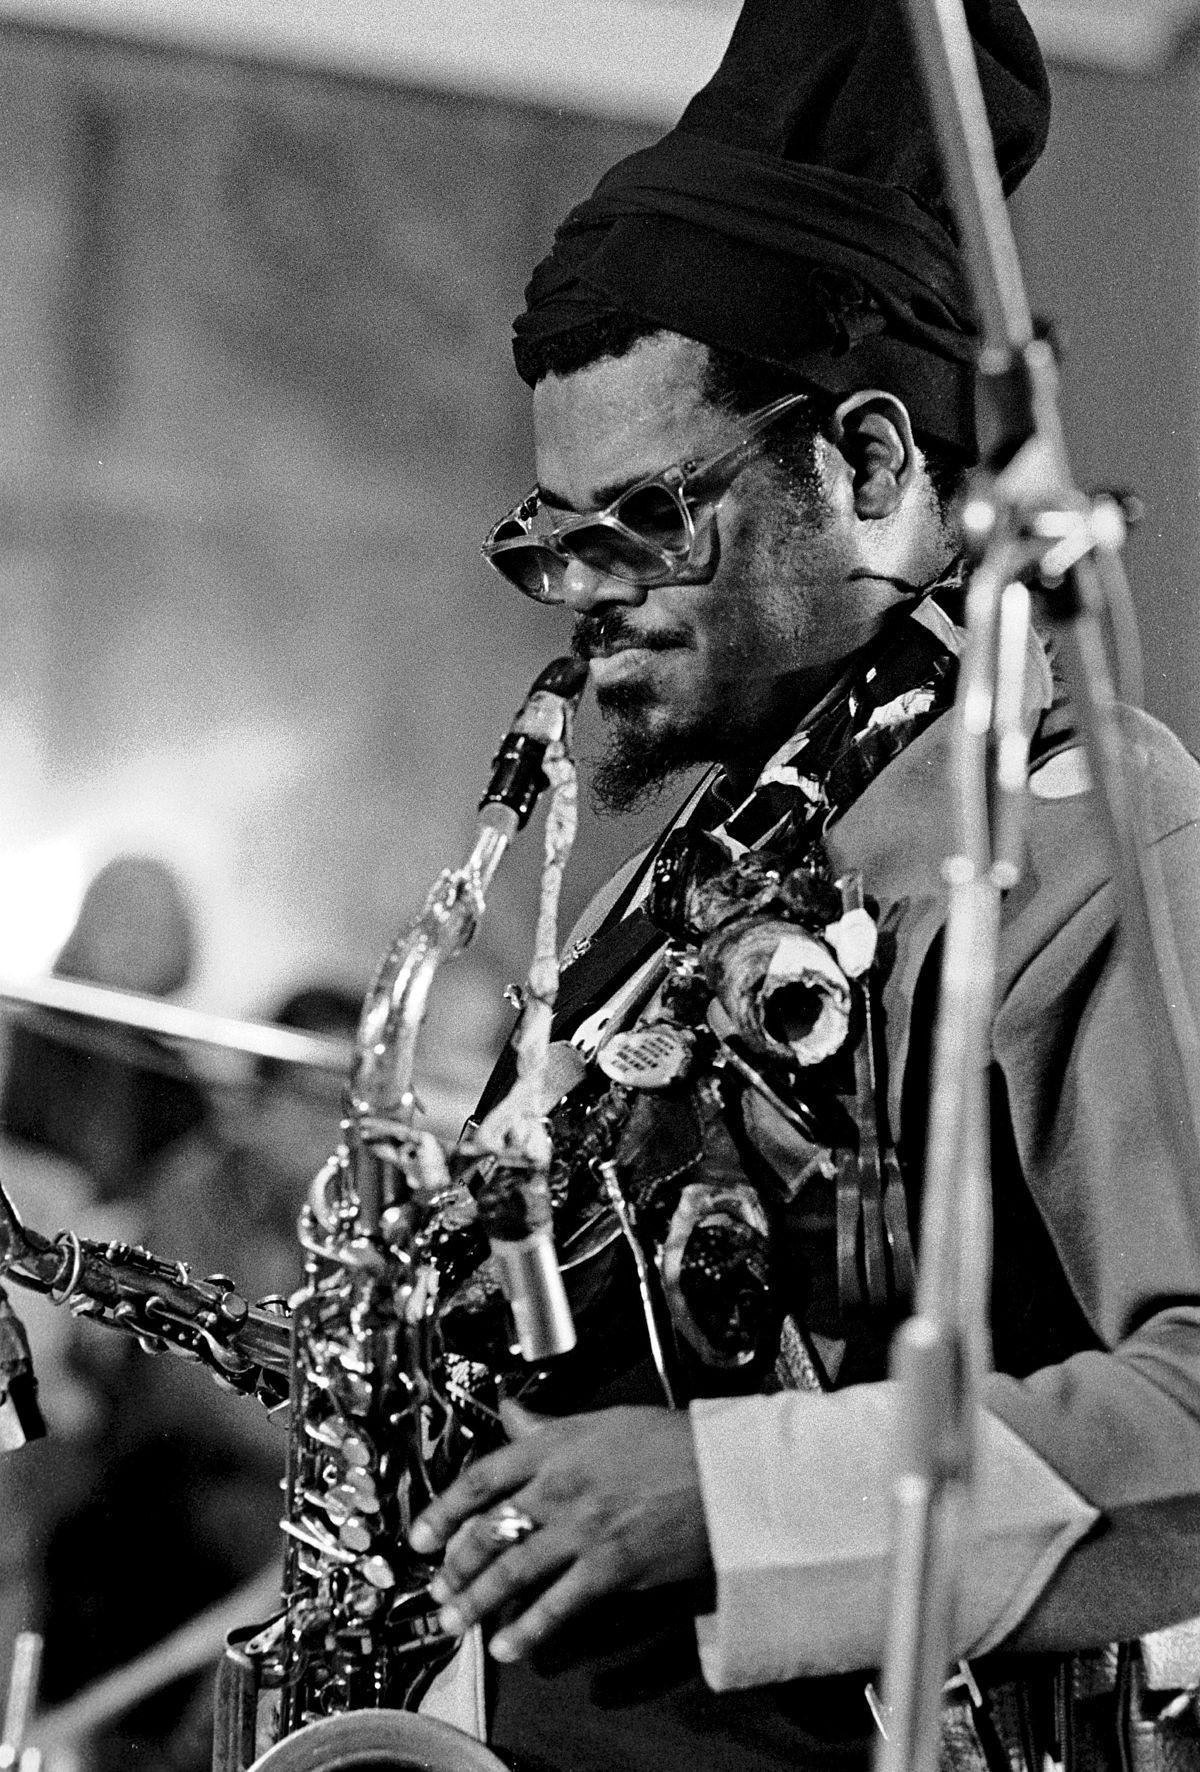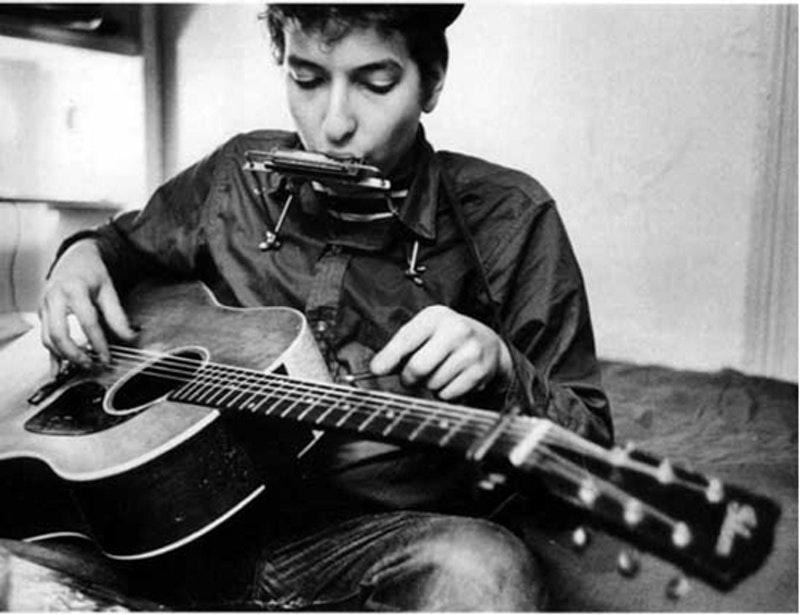The first image is the image on the left, the second image is the image on the right. Considering the images on both sides, is "In one of the image there is a man playing a guitar in his lap." valid? Answer yes or no. Yes. The first image is the image on the left, the second image is the image on the right. For the images displayed, is the sentence "A musician is holding a guitar in the right image." factually correct? Answer yes or no. Yes. 